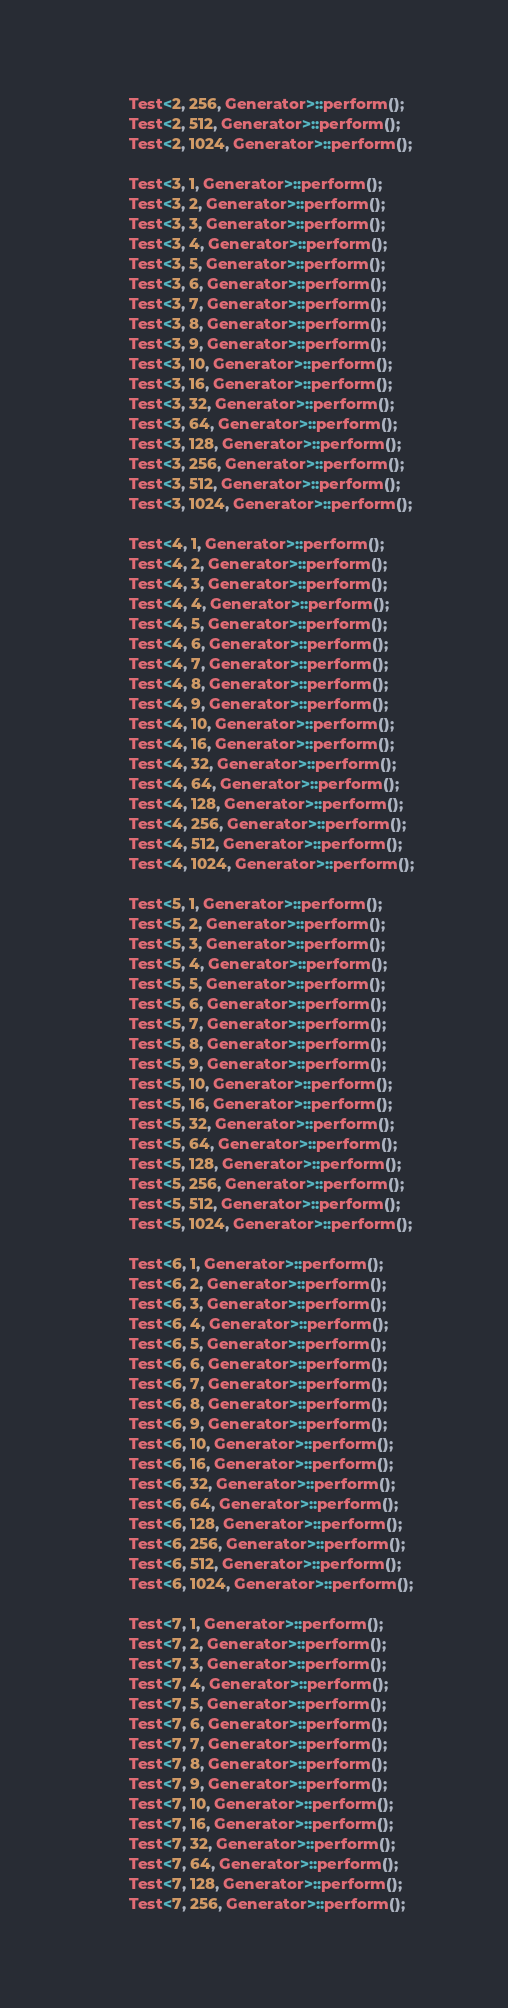<code> <loc_0><loc_0><loc_500><loc_500><_C++_>        Test<2, 256, Generator>::perform();
        Test<2, 512, Generator>::perform();
        Test<2, 1024, Generator>::perform();

        Test<3, 1, Generator>::perform();
        Test<3, 2, Generator>::perform();
        Test<3, 3, Generator>::perform();
        Test<3, 4, Generator>::perform();
        Test<3, 5, Generator>::perform();
        Test<3, 6, Generator>::perform();
        Test<3, 7, Generator>::perform();
        Test<3, 8, Generator>::perform();
        Test<3, 9, Generator>::perform();
        Test<3, 10, Generator>::perform();
        Test<3, 16, Generator>::perform();
        Test<3, 32, Generator>::perform();
        Test<3, 64, Generator>::perform();
        Test<3, 128, Generator>::perform();
        Test<3, 256, Generator>::perform();
        Test<3, 512, Generator>::perform();
        Test<3, 1024, Generator>::perform();

        Test<4, 1, Generator>::perform();
        Test<4, 2, Generator>::perform();
        Test<4, 3, Generator>::perform();
        Test<4, 4, Generator>::perform();
        Test<4, 5, Generator>::perform();
        Test<4, 6, Generator>::perform();
        Test<4, 7, Generator>::perform();
        Test<4, 8, Generator>::perform();
        Test<4, 9, Generator>::perform();
        Test<4, 10, Generator>::perform();
        Test<4, 16, Generator>::perform();
        Test<4, 32, Generator>::perform();
        Test<4, 64, Generator>::perform();
        Test<4, 128, Generator>::perform();
        Test<4, 256, Generator>::perform();
        Test<4, 512, Generator>::perform();
        Test<4, 1024, Generator>::perform();

        Test<5, 1, Generator>::perform();
        Test<5, 2, Generator>::perform();
        Test<5, 3, Generator>::perform();
        Test<5, 4, Generator>::perform();
        Test<5, 5, Generator>::perform();
        Test<5, 6, Generator>::perform();
        Test<5, 7, Generator>::perform();
        Test<5, 8, Generator>::perform();
        Test<5, 9, Generator>::perform();
        Test<5, 10, Generator>::perform();
        Test<5, 16, Generator>::perform();
        Test<5, 32, Generator>::perform();
        Test<5, 64, Generator>::perform();
        Test<5, 128, Generator>::perform();
        Test<5, 256, Generator>::perform();
        Test<5, 512, Generator>::perform();
        Test<5, 1024, Generator>::perform();

        Test<6, 1, Generator>::perform();
        Test<6, 2, Generator>::perform();
        Test<6, 3, Generator>::perform();
        Test<6, 4, Generator>::perform();
        Test<6, 5, Generator>::perform();
        Test<6, 6, Generator>::perform();
        Test<6, 7, Generator>::perform();
        Test<6, 8, Generator>::perform();
        Test<6, 9, Generator>::perform();
        Test<6, 10, Generator>::perform();
        Test<6, 16, Generator>::perform();
        Test<6, 32, Generator>::perform();
        Test<6, 64, Generator>::perform();
        Test<6, 128, Generator>::perform();
        Test<6, 256, Generator>::perform();
        Test<6, 512, Generator>::perform();
        Test<6, 1024, Generator>::perform();

        Test<7, 1, Generator>::perform();
        Test<7, 2, Generator>::perform();
        Test<7, 3, Generator>::perform();
        Test<7, 4, Generator>::perform();
        Test<7, 5, Generator>::perform();
        Test<7, 6, Generator>::perform();
        Test<7, 7, Generator>::perform();
        Test<7, 8, Generator>::perform();
        Test<7, 9, Generator>::perform();
        Test<7, 10, Generator>::perform();
        Test<7, 16, Generator>::perform();
        Test<7, 32, Generator>::perform();
        Test<7, 64, Generator>::perform();
        Test<7, 128, Generator>::perform();
        Test<7, 256, Generator>::perform();</code> 